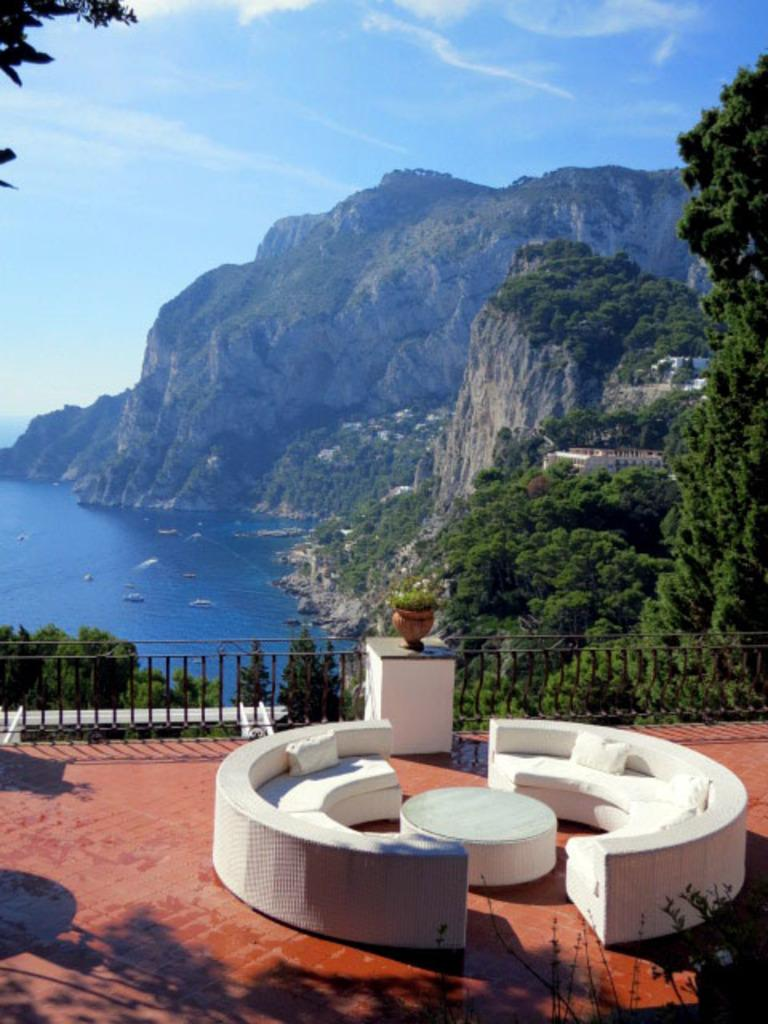What type of furniture is present in the image? There are sofas in the image. What can be seen on the sofas? There are pillows on the sofas. What is the primary piece of furniture in the image? There is a table in the image. What is the surface on which the furniture is placed? There is a floor in the image. What architectural feature is present in the image? There is a railing in the image. What type of greenery is visible in the image? There are plants and trees in the image. What body of water is visible in the image? There is water visible in the image. What type of structure is present in the image? There is a building in the image. What type of transportation is visible in the image? There are boats in the image. What type of natural landscape is visible in the background? In the background, there are hills visible. What is visible in the sky in the background? The sky is visible in the background, and clouds are present. How much sugar is present in the image? There is no reference to sugar in the image, so it cannot be determined. Is there a kite flying in the image? There is no kite present in the image. 